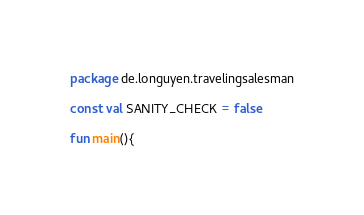<code> <loc_0><loc_0><loc_500><loc_500><_Kotlin_>package de.longuyen.travelingsalesman

const val SANITY_CHECK = false

fun main(){</code> 